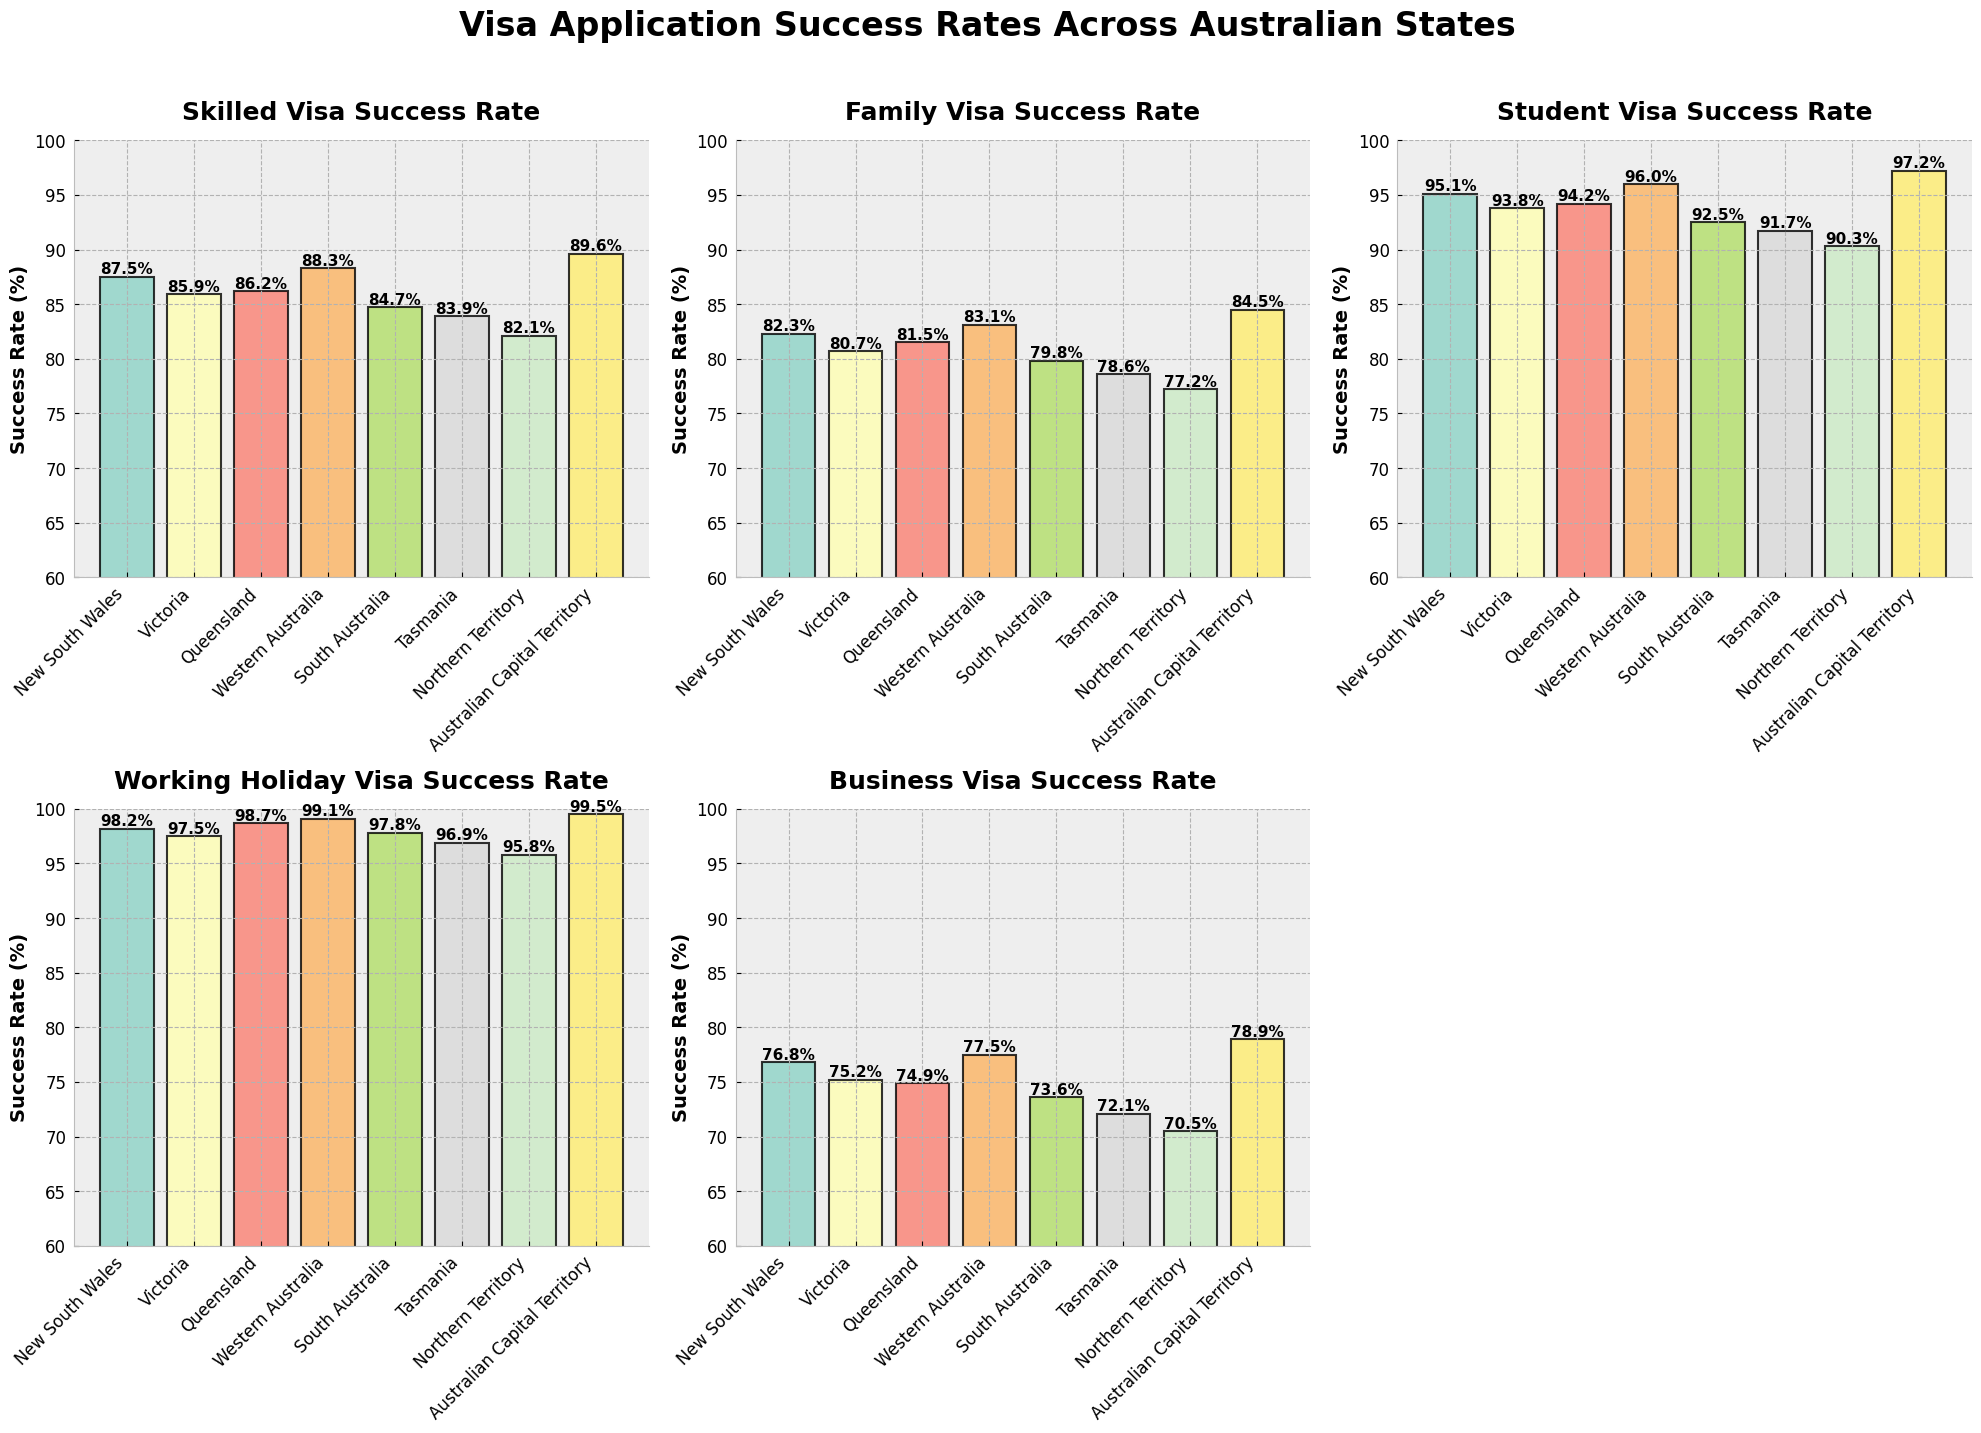What is the title of the whole figure? The title is located at the top of the figure in large, bold text. A standard title provides a clear summary of what the figure represents.
Answer: Visa Application Success Rates Across Australian States Which state has the highest success rate for Skilled Visa applications? Look at the subplot labeled "Skilled Visa Success Rate" and identify the tallest bar. The label of this bar indicates the state with the highest rate.
Answer: Australian Capital Territory Between New South Wales and Victoria, which state has a higher success rate for Student Visa applications? Look at the subplot labeled "Student Visa Success Rate" and compare the height of the bars for New South Wales and Victoria. New South Wales' bar is slightly taller.
Answer: New South Wales Which visa type has the highest overall success rates across all states? Compare the average success rate across all states for each visa in their respective subplots. The "Working Holiday Visa" consistently shows high success rates close to 100% across all states.
Answer: Working Holiday Visa What is the difference in success rate for Business Visas between Western Australia and Northern Territory? Look at the subplot labeled "Business Visa Success Rate" and find the heights of the bars for Western Australia and Northern Territory. Subtract Northern Territory's rate from Western Australia's rate.
Answer: 7.0% How many subplots are shown in the figure? Count the total number of individual panels or charts within the entire figure layout. The arrangement features multiple panels to encompass different visa types.
Answer: 5 Which state has the lowest success rate for Family Visa applications? In the subplot labeled "Family Visa Success Rate," find the shortest bar and read its corresponding state label.
Answer: Northern Territory If you combine the success rates for Skilled Visa and Family Visa in Tasmania, what is the total rate? Locate the subplot for Skilled Visa and Family Visa. Read the values for Tasmania from each and add them together: 83.9% (Skilled) + 78.6% (Family) = 162.5%.
Answer: 162.5% What is the average success rate for Business Visas across all states? Sum all the success rates for Business Visas provided in the data and divide by the number of states (8). (76.8+75.2+74.9+77.5+73.6+72.1+70.5+78.9)/8 = 599.5/8.
Answer: 74.9% Which visa type shows the most significant variation in success rate among the states? Compare the range of success rates (difference between highest and lowest) for each visa type across the states in their respective subplots. The Business Visa type shows the broadest range.
Answer: Business Visa 